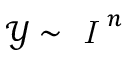Convert formula to latex. <formula><loc_0><loc_0><loc_500><loc_500>\mathcal { Y } \sim \emph { I } ^ { n }</formula> 